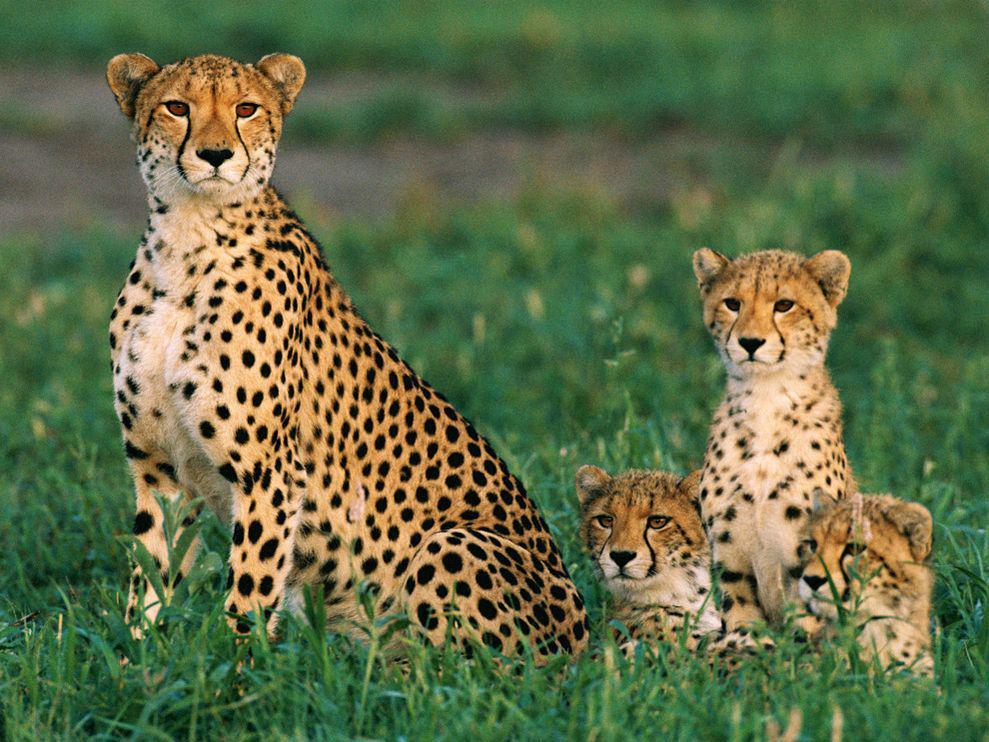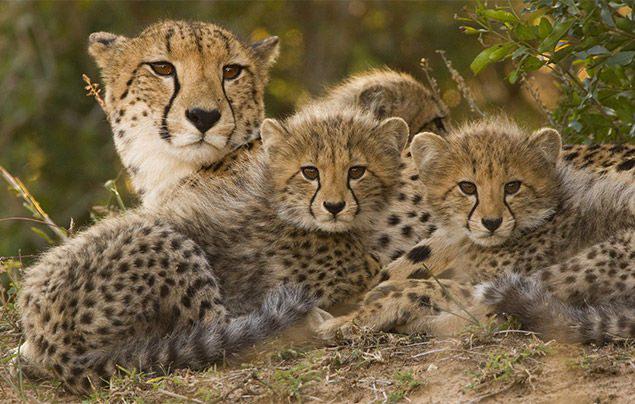The first image is the image on the left, the second image is the image on the right. Assess this claim about the two images: "The same number of cheetahs are present in the left and right images.". Correct or not? Answer yes or no. Yes. 